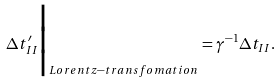<formula> <loc_0><loc_0><loc_500><loc_500>\Delta t ^ { \prime } _ { I I } \Big | _ { L o r e n t z - t r a n s f o m a t i o n } = \gamma ^ { - 1 } \Delta t _ { I I } .</formula> 